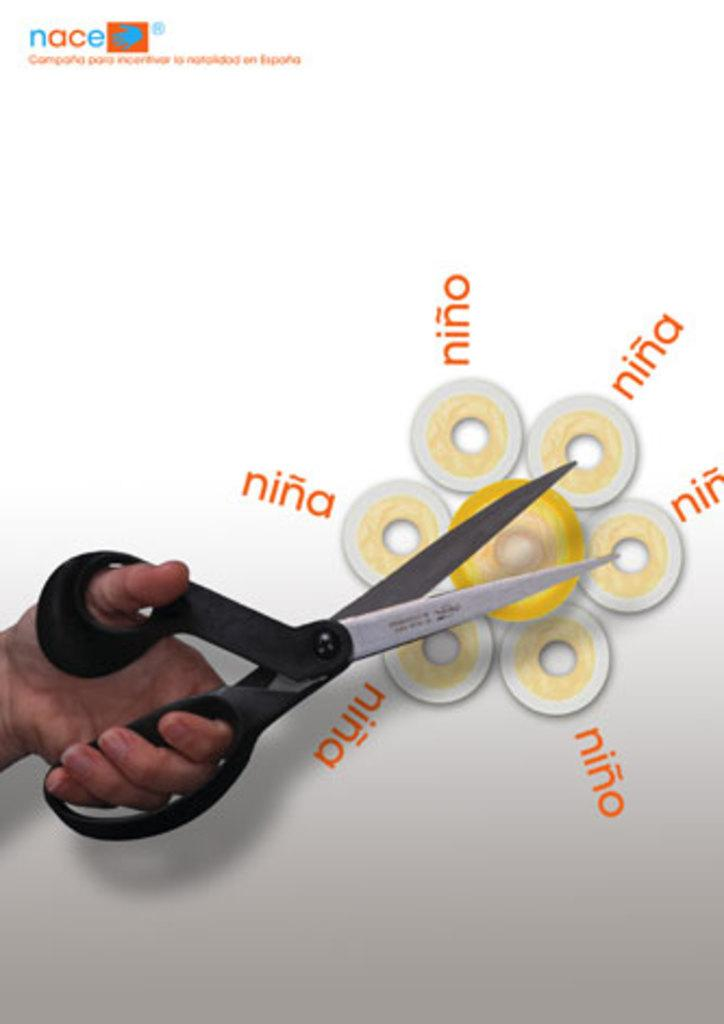What can be seen in the person's hand in the image? The hand is holding a black color scissor. What is the background of the image? There is a white color hoarding in the image. What is unique about the hoarding? The hoarding has a watermark. What else is present on the hoarding? There are words and an image on the hoarding. Is the person in the image trying to escape from quicksand? There is no quicksand present in the image, and the person's hand holding a scissor suggests a different context. 